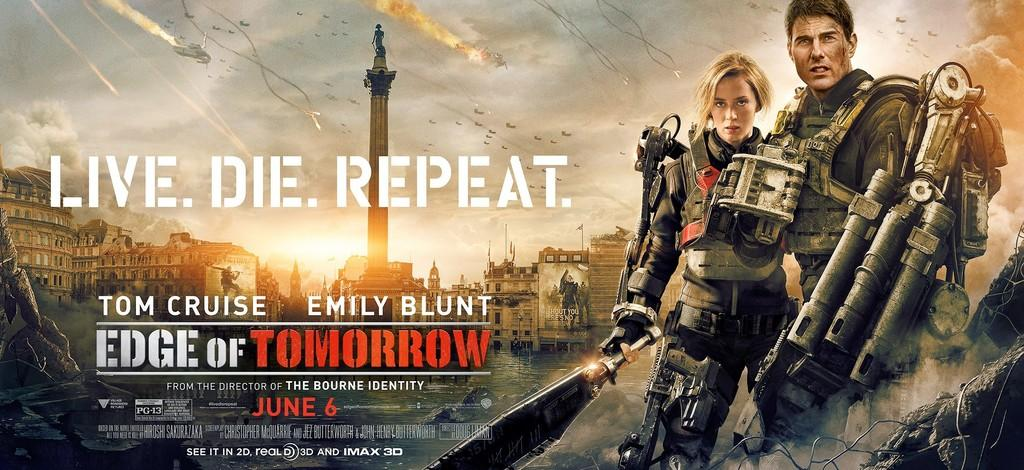Provide a one-sentence caption for the provided image. an image for a movie that is called Edge of Tomorrow. 